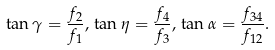Convert formula to latex. <formula><loc_0><loc_0><loc_500><loc_500>\tan \gamma = \frac { f _ { 2 } } { f _ { 1 } } , \, \tan \eta = \frac { f _ { 4 } } { f _ { 3 } } , \, \tan \alpha = \frac { f _ { 3 4 } } { f _ { 1 2 } } .</formula> 